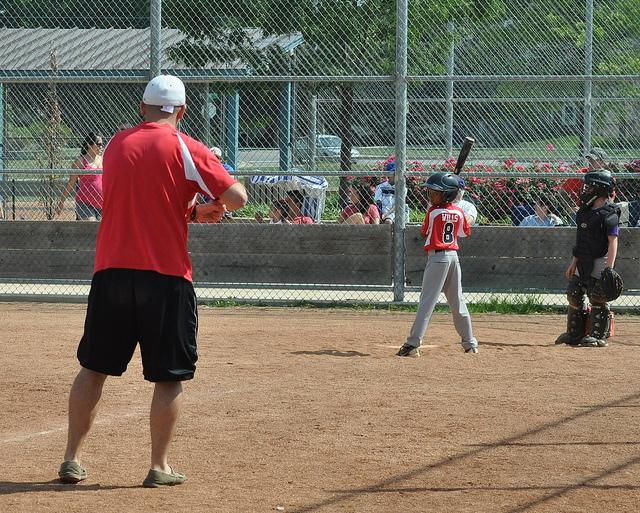What type of field are the kids playing on?

Choices:
A) softball
B) soccer
C) lacrosse
D) football softball 